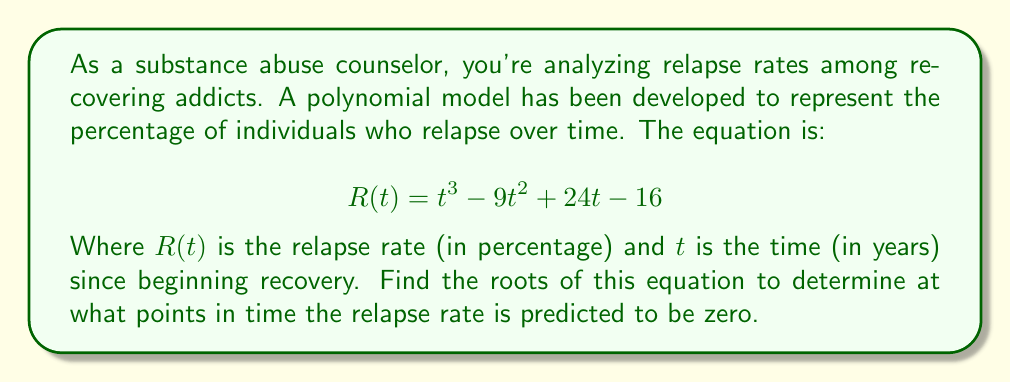Can you answer this question? To find the roots of this polynomial equation, we need to factor it and solve for $t$ when $R(t) = 0$.

1) First, let's check if there's a common factor:
   There isn't any common factor for all terms.

2) Next, we can try to guess one root. Let's try some integer values:
   When $t = 1$: $R(1) = 1^3 - 9(1)^2 + 24(1) - 16 = 1 - 9 + 24 - 16 = 0$
   So, $(t - 1)$ is a factor.

3) We can divide the polynomial by $(t - 1)$ to find the other factors:

   $$\begin{array}{r}
   t^2 - 8t + 16 \\
   t - 1 \enclose{longdiv}{t^3 - 9t^2 + 24t - 16} \\
   \underline{t^3 - t^2} \\
   -8t^2 + 24t \\
   \underline{-8t^2 + 8t} \\
   16t - 16 \\
   \underline{16t - 16} \\
   0
   \end{array}$$

4) So, $R(t) = (t - 1)(t^2 - 8t + 16)$

5) We can factor the quadratic term further:
   $t^2 - 8t + 16 = (t - 4)^2$

6) Therefore, the fully factored polynomial is:
   $R(t) = (t - 1)(t - 4)^2$

7) The roots are the values of $t$ that make each factor equal to zero:
   $t - 1 = 0$ or $(t - 4)^2 = 0$
   $t = 1$ or $t = 4$

Thus, the relapse rate is predicted to be zero at 1 year and 4 years after beginning recovery.
Answer: The roots of the polynomial equation are $t = 1$ and $t = 4$ (with $t = 4$ being a double root). 